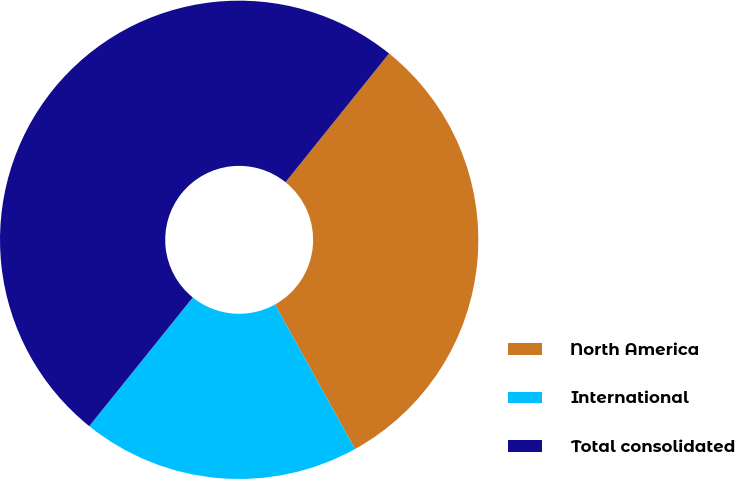<chart> <loc_0><loc_0><loc_500><loc_500><pie_chart><fcel>North America<fcel>International<fcel>Total consolidated<nl><fcel>31.17%<fcel>18.83%<fcel>50.0%<nl></chart> 